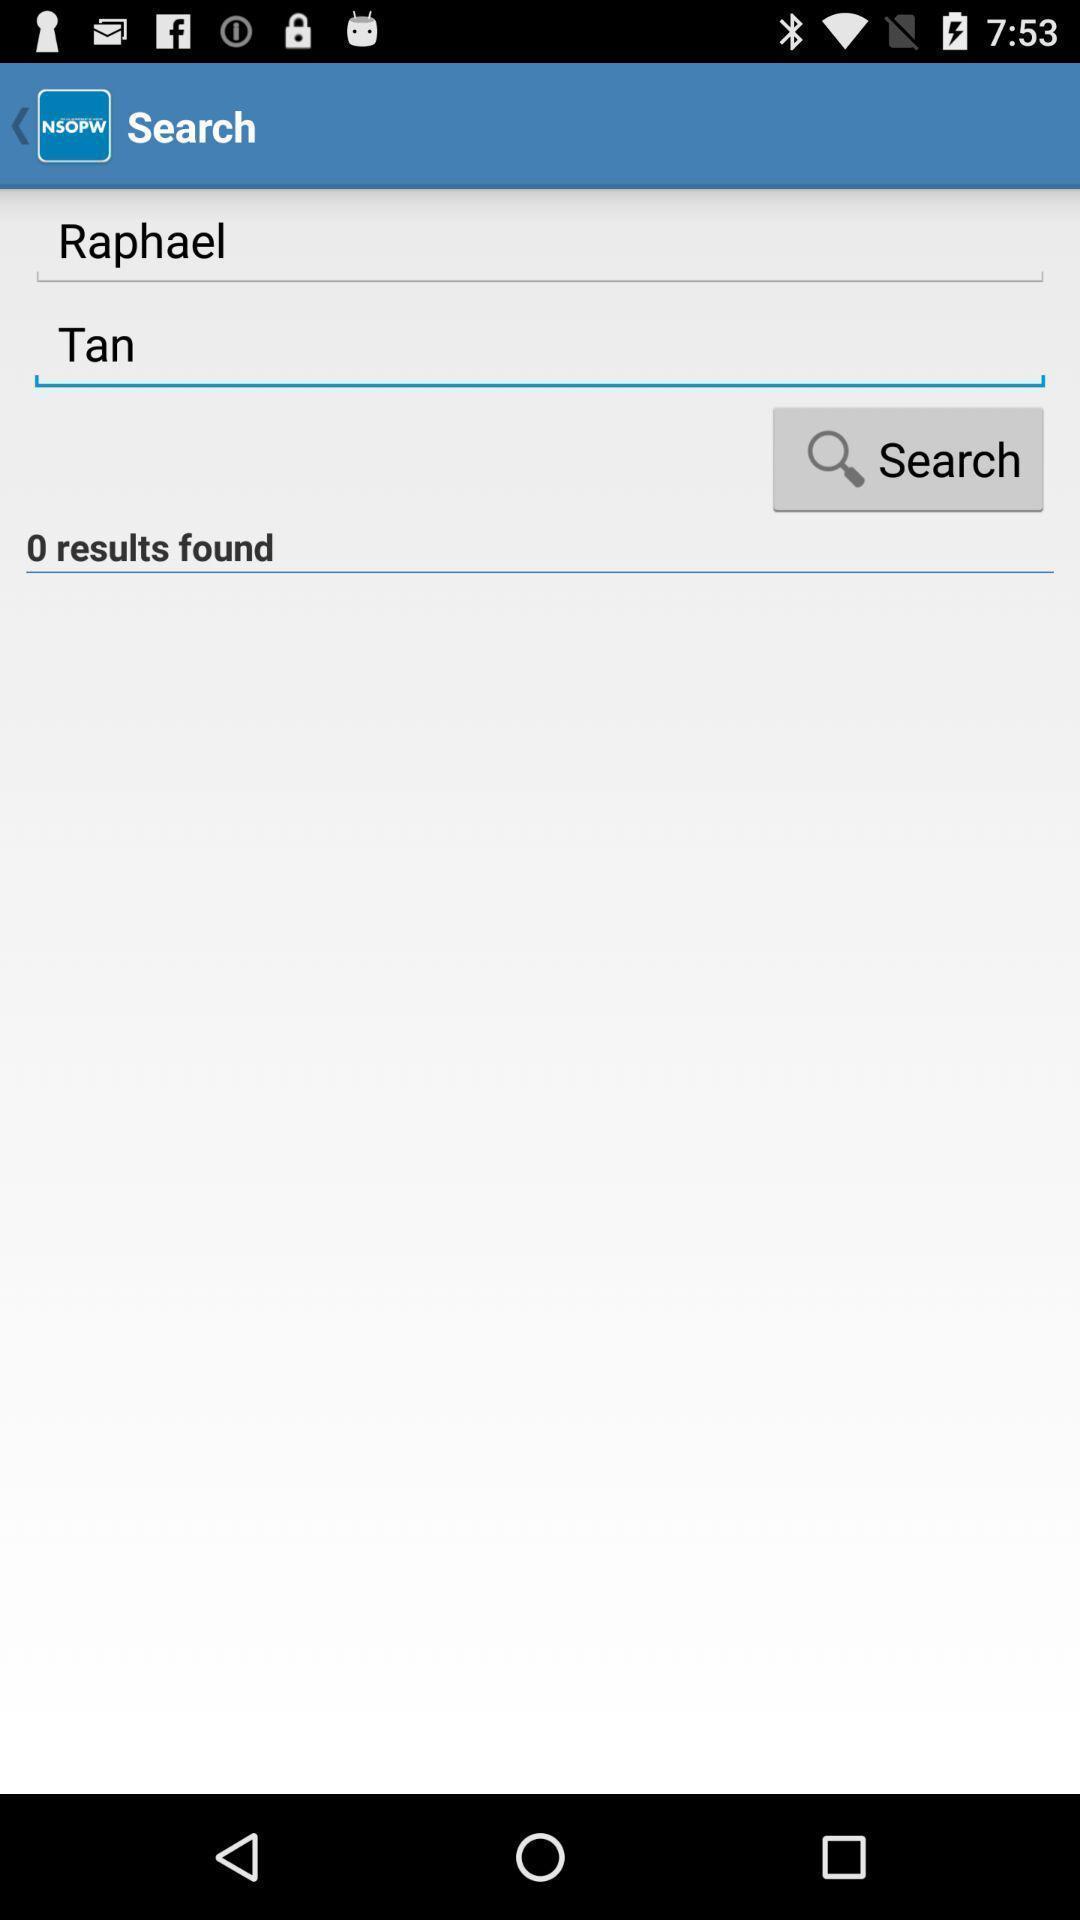Provide a detailed account of this screenshot. Search bar to search names in app. 